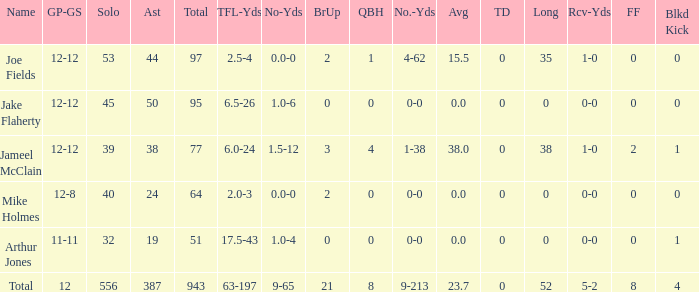What is the combined brup for the team? 21.0. 